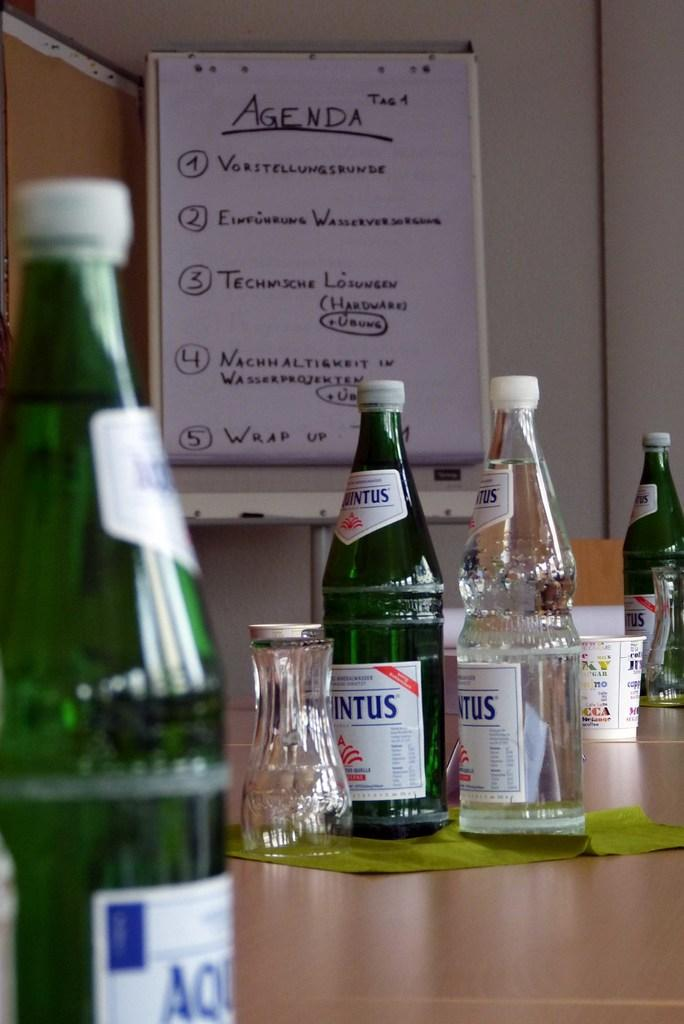<image>
Give a short and clear explanation of the subsequent image. the word agenda is written on the wall 